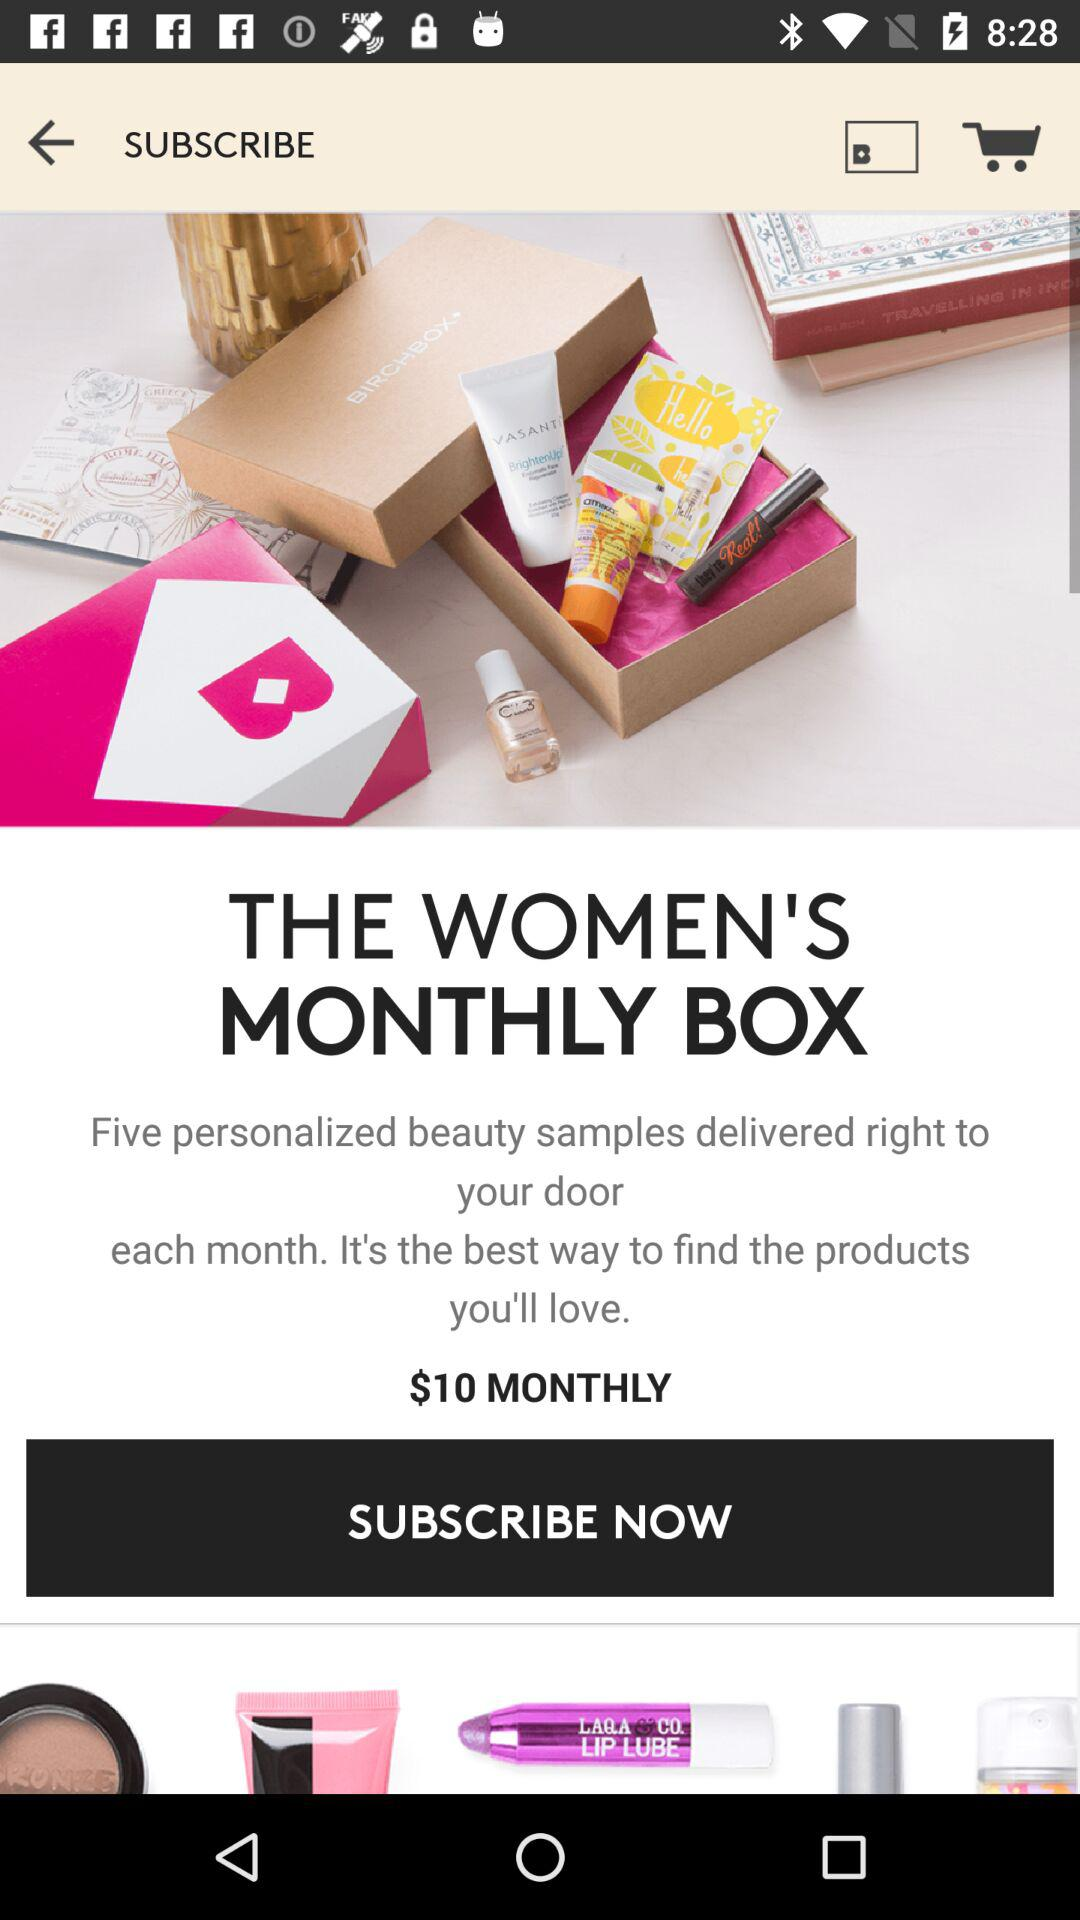What is the price of a monthly subscription? The price is $10. 